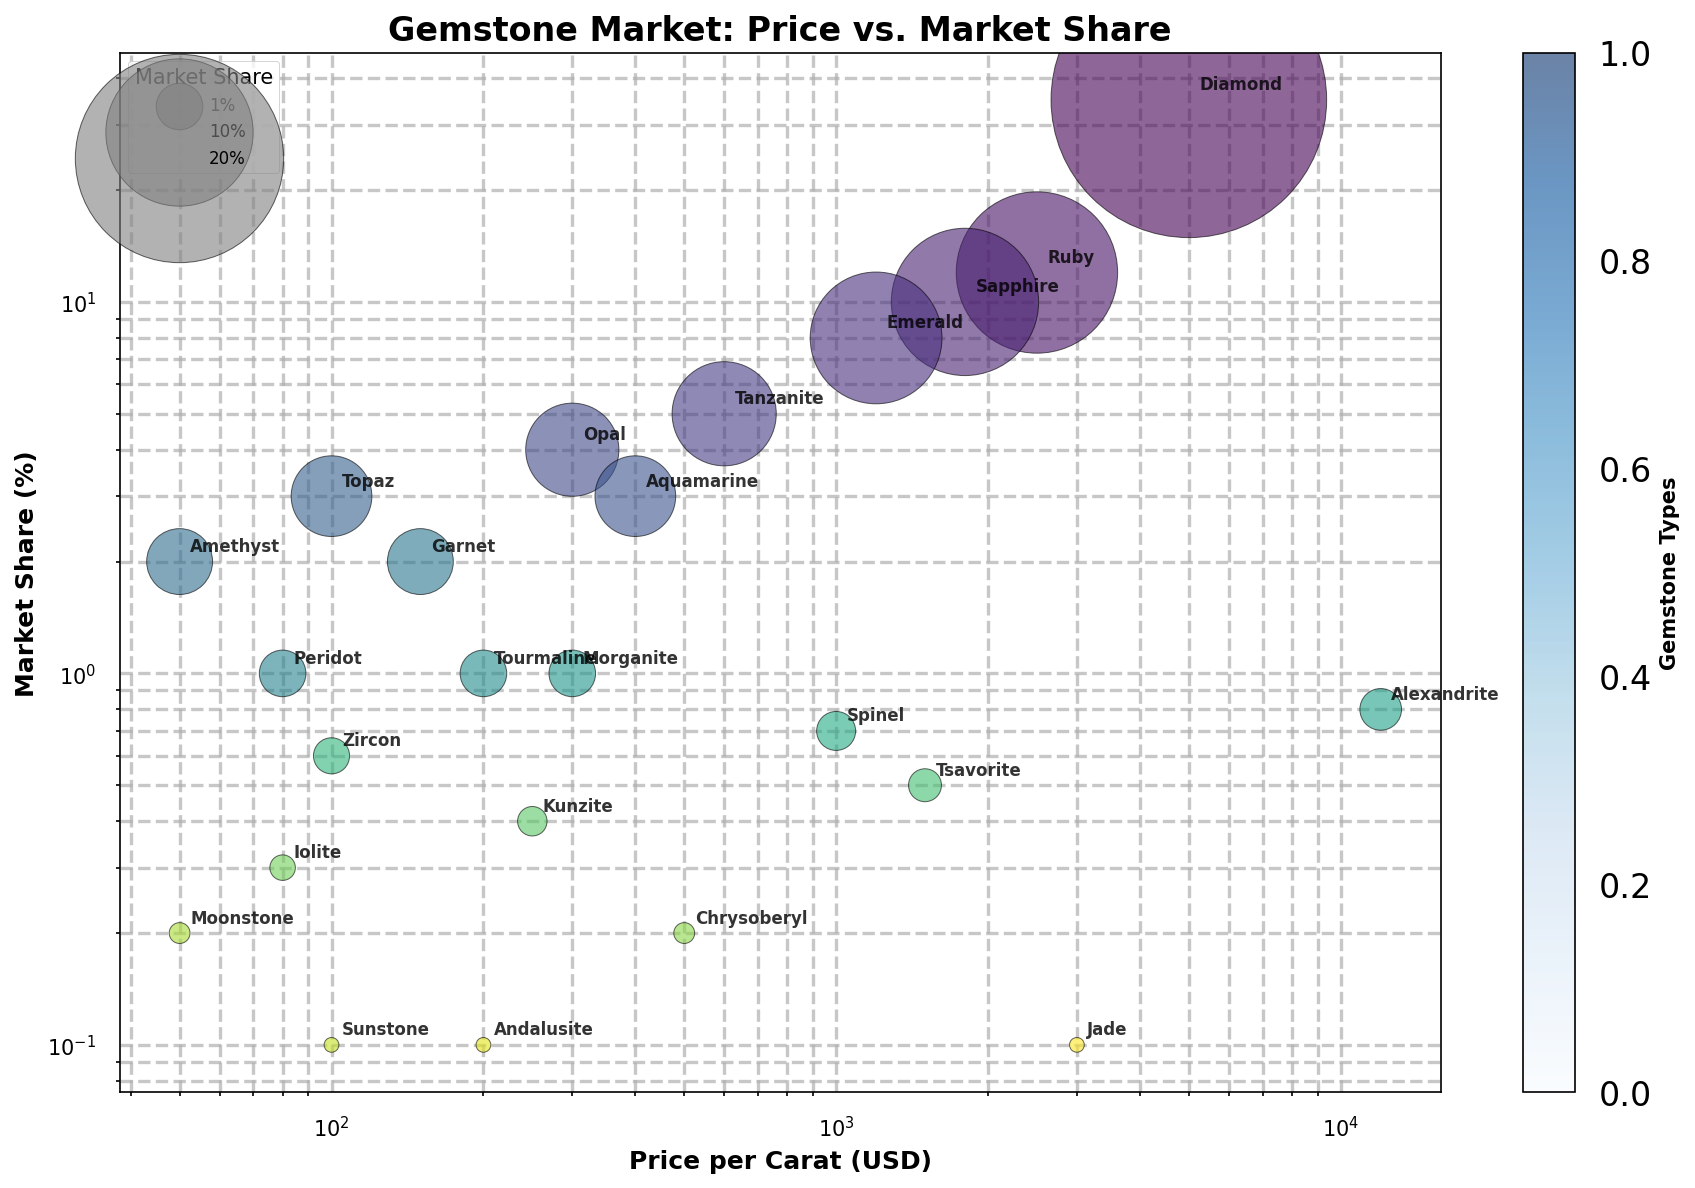Which gemstone has the highest market share? Observe the y-axis (Market Share) and identify the gemstone label at the highest point.
Answer: Diamond Which gemstone has the highest price per carat? Observe the x-axis (Price per Carat) and identify the gemstone label at the furthest right.
Answer: Alexandrite What is the market share of gemstones from Brazil that are not treated with heat? Sum the market shares of Aquamarine, Topaz, Amethyst, Tourmaline, Morganite, Andalusite which are not treated with heat (Tourmaline 1%, Amethyst 2%, Tourmaline 1%, Andalusite 0.1%)
Answer: 4.1% Which gemstone has a higher market share, Tanzanite or Topaz? Compare the y-values (Market Share) of Tanzanite and Topaz. Tanzanite has a higher y-value, so it has a higher market share.
Answer: Tanzanite Which is more expensive on a per-carat basis, Tanzanite or Opal? Compare the x-values (Price per Carat) of Tanzanite and Opal. Tanzanite has a higher x-value, so it is more expensive per carat.
Answer: Tanzanite What is the combined market share of the top three gemstones? Sum the market share values of the top three gemstones: Diamond (35%), Ruby (12%), and Sapphire (10%).
Answer: 57% Are there more untreated or heat-treated gemstones in the chart? Count the number of gemstones labeled with 'None' under Treatment and compare with those labeled 'Heat'. There are more untreated gemstones.
Answer: Untreated Which gemstone from Sri Lanka is displayed in the chart? Identify the gemstone label with Origin as Sri Lanka.
Answer: Sapphire What is the market share difference between Ruby and Emerald? Subtract the market share of Emerald (8%) from Ruby (12%).
Answer: 4% Which gemstones have a market share of less than 1%? Identify the gemstones with y-values (Market Share) less than 1%.
Answer: Alexandrite, Spinel, Zircon, Tsavorite, Kunzite, Iolite, Chrysoberyl, Moonstone, Sunstone, Andalusite, Jade 